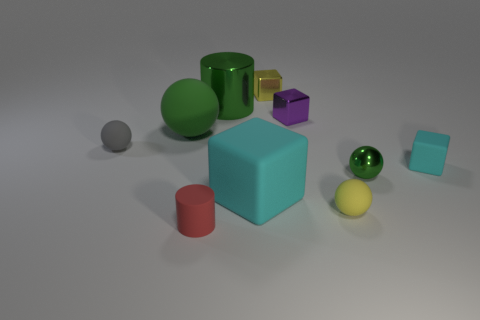Is there a pattern to how the objects are arranged? The objects appear to be arranged randomly; however, there is a slight cluster in the center with diverse shapes and sizes represented, possibly to demonstrate contrast in forms and textures. Does the arrangement suggest any particular use or purpose for these objects? Considering the varied shapes, sizes, and materials, this arrangement doesn't suggest a practical use but rather an artistic or educational display meant to showcase the differences and similarities among the objects. 